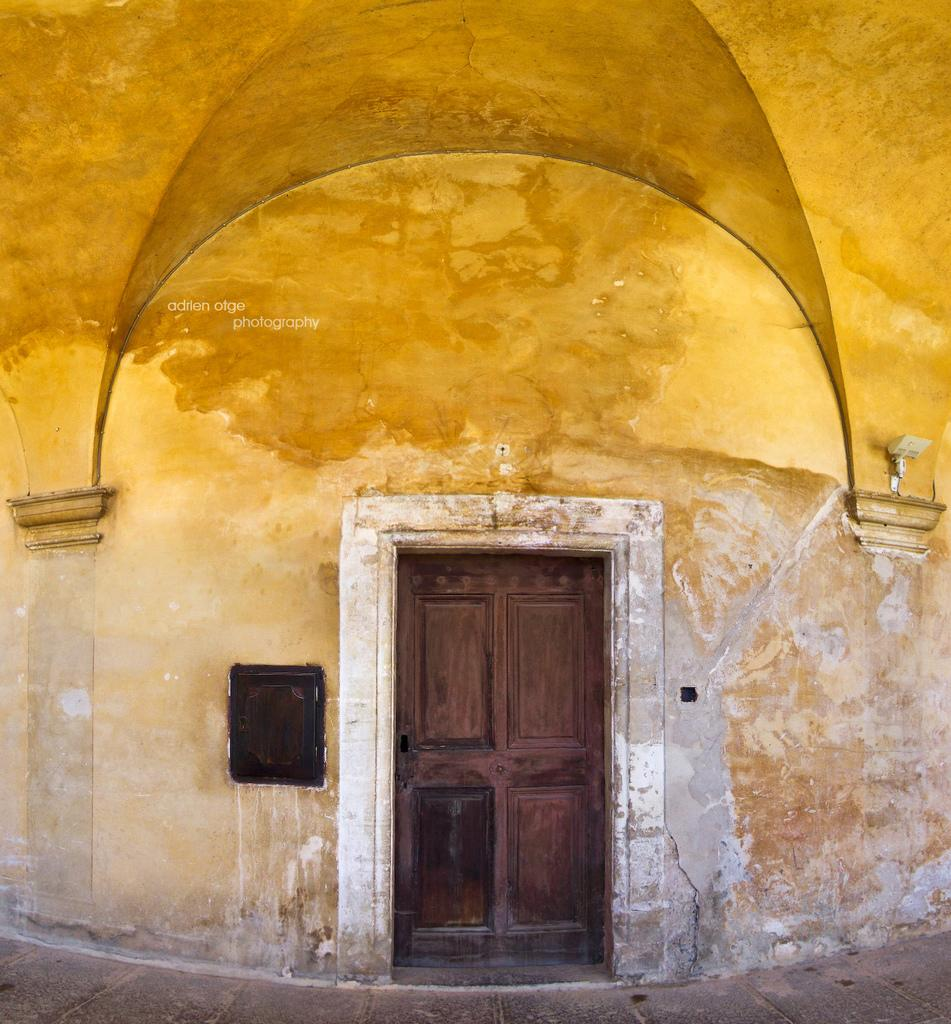What is the main structure in the image? There is a building in the image. Can you describe any objects on the building? There is a black and white object on the building. What else can be seen on the building? There is text visible on the building. What type of error can be seen on the building in the image? There is no error visible on the building in the image. Can you tell me how many stoves are present on the building? There are no stoves present on the building in the image. 